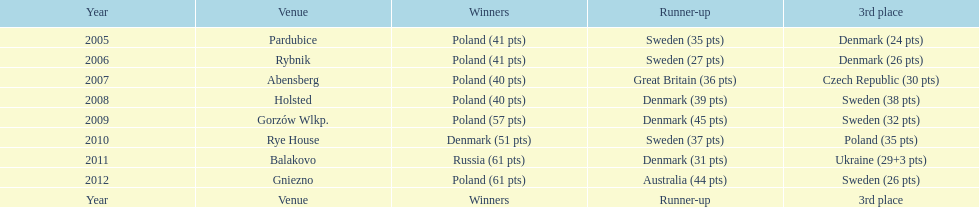What is the total number of points earned in the years 2009? 134. 